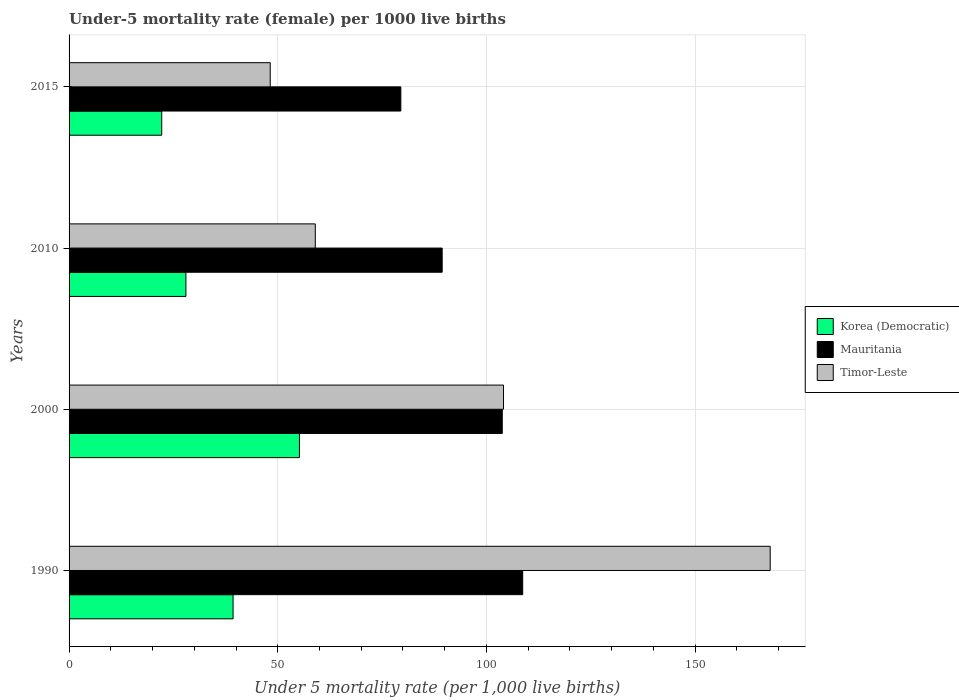How many groups of bars are there?
Provide a succinct answer. 4. Are the number of bars per tick equal to the number of legend labels?
Your answer should be very brief. Yes. How many bars are there on the 2nd tick from the top?
Your answer should be compact. 3. How many bars are there on the 1st tick from the bottom?
Your answer should be very brief. 3. What is the label of the 1st group of bars from the top?
Ensure brevity in your answer.  2015. In how many cases, is the number of bars for a given year not equal to the number of legend labels?
Provide a succinct answer. 0. What is the under-five mortality rate in Korea (Democratic) in 1990?
Offer a terse response. 39.3. Across all years, what is the maximum under-five mortality rate in Korea (Democratic)?
Your answer should be compact. 55.2. Across all years, what is the minimum under-five mortality rate in Mauritania?
Provide a short and direct response. 79.5. In which year was the under-five mortality rate in Timor-Leste minimum?
Make the answer very short. 2015. What is the total under-five mortality rate in Mauritania in the graph?
Provide a short and direct response. 381.4. What is the difference between the under-five mortality rate in Mauritania in 2000 and that in 2010?
Give a very brief answer. 14.4. What is the difference between the under-five mortality rate in Korea (Democratic) in 1990 and the under-five mortality rate in Timor-Leste in 2015?
Provide a short and direct response. -8.9. What is the average under-five mortality rate in Korea (Democratic) per year?
Ensure brevity in your answer.  36.17. In the year 1990, what is the difference between the under-five mortality rate in Mauritania and under-five mortality rate in Korea (Democratic)?
Offer a very short reply. 69.4. In how many years, is the under-five mortality rate in Timor-Leste greater than 30 ?
Keep it short and to the point. 4. What is the ratio of the under-five mortality rate in Timor-Leste in 1990 to that in 2015?
Provide a short and direct response. 3.49. Is the under-five mortality rate in Timor-Leste in 1990 less than that in 2000?
Keep it short and to the point. No. What is the difference between the highest and the second highest under-five mortality rate in Mauritania?
Your response must be concise. 4.9. What is the difference between the highest and the lowest under-five mortality rate in Timor-Leste?
Make the answer very short. 119.8. In how many years, is the under-five mortality rate in Timor-Leste greater than the average under-five mortality rate in Timor-Leste taken over all years?
Your response must be concise. 2. What does the 3rd bar from the top in 2015 represents?
Offer a very short reply. Korea (Democratic). What does the 3rd bar from the bottom in 2000 represents?
Make the answer very short. Timor-Leste. Is it the case that in every year, the sum of the under-five mortality rate in Timor-Leste and under-five mortality rate in Korea (Democratic) is greater than the under-five mortality rate in Mauritania?
Your answer should be very brief. No. How many years are there in the graph?
Your answer should be very brief. 4. Does the graph contain grids?
Offer a terse response. Yes. Where does the legend appear in the graph?
Your response must be concise. Center right. How many legend labels are there?
Ensure brevity in your answer.  3. What is the title of the graph?
Ensure brevity in your answer.  Under-5 mortality rate (female) per 1000 live births. Does "Luxembourg" appear as one of the legend labels in the graph?
Keep it short and to the point. No. What is the label or title of the X-axis?
Your answer should be compact. Under 5 mortality rate (per 1,0 live births). What is the label or title of the Y-axis?
Your response must be concise. Years. What is the Under 5 mortality rate (per 1,000 live births) in Korea (Democratic) in 1990?
Your answer should be very brief. 39.3. What is the Under 5 mortality rate (per 1,000 live births) in Mauritania in 1990?
Keep it short and to the point. 108.7. What is the Under 5 mortality rate (per 1,000 live births) in Timor-Leste in 1990?
Ensure brevity in your answer.  168. What is the Under 5 mortality rate (per 1,000 live births) in Korea (Democratic) in 2000?
Provide a short and direct response. 55.2. What is the Under 5 mortality rate (per 1,000 live births) in Mauritania in 2000?
Your answer should be compact. 103.8. What is the Under 5 mortality rate (per 1,000 live births) in Timor-Leste in 2000?
Offer a very short reply. 104.1. What is the Under 5 mortality rate (per 1,000 live births) in Korea (Democratic) in 2010?
Provide a succinct answer. 28. What is the Under 5 mortality rate (per 1,000 live births) of Mauritania in 2010?
Provide a short and direct response. 89.4. What is the Under 5 mortality rate (per 1,000 live births) of Timor-Leste in 2010?
Provide a succinct answer. 59. What is the Under 5 mortality rate (per 1,000 live births) in Mauritania in 2015?
Offer a very short reply. 79.5. What is the Under 5 mortality rate (per 1,000 live births) of Timor-Leste in 2015?
Ensure brevity in your answer.  48.2. Across all years, what is the maximum Under 5 mortality rate (per 1,000 live births) in Korea (Democratic)?
Make the answer very short. 55.2. Across all years, what is the maximum Under 5 mortality rate (per 1,000 live births) in Mauritania?
Offer a very short reply. 108.7. Across all years, what is the maximum Under 5 mortality rate (per 1,000 live births) of Timor-Leste?
Your answer should be very brief. 168. Across all years, what is the minimum Under 5 mortality rate (per 1,000 live births) in Mauritania?
Offer a terse response. 79.5. Across all years, what is the minimum Under 5 mortality rate (per 1,000 live births) of Timor-Leste?
Make the answer very short. 48.2. What is the total Under 5 mortality rate (per 1,000 live births) in Korea (Democratic) in the graph?
Your answer should be very brief. 144.7. What is the total Under 5 mortality rate (per 1,000 live births) of Mauritania in the graph?
Keep it short and to the point. 381.4. What is the total Under 5 mortality rate (per 1,000 live births) in Timor-Leste in the graph?
Offer a terse response. 379.3. What is the difference between the Under 5 mortality rate (per 1,000 live births) of Korea (Democratic) in 1990 and that in 2000?
Make the answer very short. -15.9. What is the difference between the Under 5 mortality rate (per 1,000 live births) in Timor-Leste in 1990 and that in 2000?
Offer a very short reply. 63.9. What is the difference between the Under 5 mortality rate (per 1,000 live births) in Korea (Democratic) in 1990 and that in 2010?
Provide a succinct answer. 11.3. What is the difference between the Under 5 mortality rate (per 1,000 live births) of Mauritania in 1990 and that in 2010?
Your answer should be very brief. 19.3. What is the difference between the Under 5 mortality rate (per 1,000 live births) of Timor-Leste in 1990 and that in 2010?
Offer a terse response. 109. What is the difference between the Under 5 mortality rate (per 1,000 live births) in Korea (Democratic) in 1990 and that in 2015?
Your response must be concise. 17.1. What is the difference between the Under 5 mortality rate (per 1,000 live births) in Mauritania in 1990 and that in 2015?
Provide a short and direct response. 29.2. What is the difference between the Under 5 mortality rate (per 1,000 live births) in Timor-Leste in 1990 and that in 2015?
Ensure brevity in your answer.  119.8. What is the difference between the Under 5 mortality rate (per 1,000 live births) in Korea (Democratic) in 2000 and that in 2010?
Your answer should be very brief. 27.2. What is the difference between the Under 5 mortality rate (per 1,000 live births) of Timor-Leste in 2000 and that in 2010?
Your answer should be very brief. 45.1. What is the difference between the Under 5 mortality rate (per 1,000 live births) in Mauritania in 2000 and that in 2015?
Offer a very short reply. 24.3. What is the difference between the Under 5 mortality rate (per 1,000 live births) of Timor-Leste in 2000 and that in 2015?
Your response must be concise. 55.9. What is the difference between the Under 5 mortality rate (per 1,000 live births) in Korea (Democratic) in 1990 and the Under 5 mortality rate (per 1,000 live births) in Mauritania in 2000?
Offer a terse response. -64.5. What is the difference between the Under 5 mortality rate (per 1,000 live births) of Korea (Democratic) in 1990 and the Under 5 mortality rate (per 1,000 live births) of Timor-Leste in 2000?
Your answer should be compact. -64.8. What is the difference between the Under 5 mortality rate (per 1,000 live births) in Mauritania in 1990 and the Under 5 mortality rate (per 1,000 live births) in Timor-Leste in 2000?
Make the answer very short. 4.6. What is the difference between the Under 5 mortality rate (per 1,000 live births) of Korea (Democratic) in 1990 and the Under 5 mortality rate (per 1,000 live births) of Mauritania in 2010?
Your response must be concise. -50.1. What is the difference between the Under 5 mortality rate (per 1,000 live births) in Korea (Democratic) in 1990 and the Under 5 mortality rate (per 1,000 live births) in Timor-Leste in 2010?
Make the answer very short. -19.7. What is the difference between the Under 5 mortality rate (per 1,000 live births) of Mauritania in 1990 and the Under 5 mortality rate (per 1,000 live births) of Timor-Leste in 2010?
Offer a terse response. 49.7. What is the difference between the Under 5 mortality rate (per 1,000 live births) of Korea (Democratic) in 1990 and the Under 5 mortality rate (per 1,000 live births) of Mauritania in 2015?
Offer a very short reply. -40.2. What is the difference between the Under 5 mortality rate (per 1,000 live births) in Mauritania in 1990 and the Under 5 mortality rate (per 1,000 live births) in Timor-Leste in 2015?
Keep it short and to the point. 60.5. What is the difference between the Under 5 mortality rate (per 1,000 live births) of Korea (Democratic) in 2000 and the Under 5 mortality rate (per 1,000 live births) of Mauritania in 2010?
Your response must be concise. -34.2. What is the difference between the Under 5 mortality rate (per 1,000 live births) of Korea (Democratic) in 2000 and the Under 5 mortality rate (per 1,000 live births) of Timor-Leste in 2010?
Give a very brief answer. -3.8. What is the difference between the Under 5 mortality rate (per 1,000 live births) in Mauritania in 2000 and the Under 5 mortality rate (per 1,000 live births) in Timor-Leste in 2010?
Your response must be concise. 44.8. What is the difference between the Under 5 mortality rate (per 1,000 live births) in Korea (Democratic) in 2000 and the Under 5 mortality rate (per 1,000 live births) in Mauritania in 2015?
Provide a succinct answer. -24.3. What is the difference between the Under 5 mortality rate (per 1,000 live births) in Mauritania in 2000 and the Under 5 mortality rate (per 1,000 live births) in Timor-Leste in 2015?
Provide a succinct answer. 55.6. What is the difference between the Under 5 mortality rate (per 1,000 live births) in Korea (Democratic) in 2010 and the Under 5 mortality rate (per 1,000 live births) in Mauritania in 2015?
Your answer should be compact. -51.5. What is the difference between the Under 5 mortality rate (per 1,000 live births) in Korea (Democratic) in 2010 and the Under 5 mortality rate (per 1,000 live births) in Timor-Leste in 2015?
Provide a succinct answer. -20.2. What is the difference between the Under 5 mortality rate (per 1,000 live births) in Mauritania in 2010 and the Under 5 mortality rate (per 1,000 live births) in Timor-Leste in 2015?
Give a very brief answer. 41.2. What is the average Under 5 mortality rate (per 1,000 live births) in Korea (Democratic) per year?
Your answer should be very brief. 36.17. What is the average Under 5 mortality rate (per 1,000 live births) of Mauritania per year?
Your answer should be compact. 95.35. What is the average Under 5 mortality rate (per 1,000 live births) of Timor-Leste per year?
Make the answer very short. 94.83. In the year 1990, what is the difference between the Under 5 mortality rate (per 1,000 live births) in Korea (Democratic) and Under 5 mortality rate (per 1,000 live births) in Mauritania?
Provide a succinct answer. -69.4. In the year 1990, what is the difference between the Under 5 mortality rate (per 1,000 live births) of Korea (Democratic) and Under 5 mortality rate (per 1,000 live births) of Timor-Leste?
Ensure brevity in your answer.  -128.7. In the year 1990, what is the difference between the Under 5 mortality rate (per 1,000 live births) in Mauritania and Under 5 mortality rate (per 1,000 live births) in Timor-Leste?
Give a very brief answer. -59.3. In the year 2000, what is the difference between the Under 5 mortality rate (per 1,000 live births) in Korea (Democratic) and Under 5 mortality rate (per 1,000 live births) in Mauritania?
Keep it short and to the point. -48.6. In the year 2000, what is the difference between the Under 5 mortality rate (per 1,000 live births) of Korea (Democratic) and Under 5 mortality rate (per 1,000 live births) of Timor-Leste?
Your response must be concise. -48.9. In the year 2010, what is the difference between the Under 5 mortality rate (per 1,000 live births) of Korea (Democratic) and Under 5 mortality rate (per 1,000 live births) of Mauritania?
Offer a very short reply. -61.4. In the year 2010, what is the difference between the Under 5 mortality rate (per 1,000 live births) in Korea (Democratic) and Under 5 mortality rate (per 1,000 live births) in Timor-Leste?
Ensure brevity in your answer.  -31. In the year 2010, what is the difference between the Under 5 mortality rate (per 1,000 live births) of Mauritania and Under 5 mortality rate (per 1,000 live births) of Timor-Leste?
Make the answer very short. 30.4. In the year 2015, what is the difference between the Under 5 mortality rate (per 1,000 live births) of Korea (Democratic) and Under 5 mortality rate (per 1,000 live births) of Mauritania?
Your answer should be very brief. -57.3. In the year 2015, what is the difference between the Under 5 mortality rate (per 1,000 live births) of Korea (Democratic) and Under 5 mortality rate (per 1,000 live births) of Timor-Leste?
Offer a terse response. -26. In the year 2015, what is the difference between the Under 5 mortality rate (per 1,000 live births) in Mauritania and Under 5 mortality rate (per 1,000 live births) in Timor-Leste?
Give a very brief answer. 31.3. What is the ratio of the Under 5 mortality rate (per 1,000 live births) in Korea (Democratic) in 1990 to that in 2000?
Give a very brief answer. 0.71. What is the ratio of the Under 5 mortality rate (per 1,000 live births) of Mauritania in 1990 to that in 2000?
Your answer should be compact. 1.05. What is the ratio of the Under 5 mortality rate (per 1,000 live births) of Timor-Leste in 1990 to that in 2000?
Offer a very short reply. 1.61. What is the ratio of the Under 5 mortality rate (per 1,000 live births) in Korea (Democratic) in 1990 to that in 2010?
Provide a short and direct response. 1.4. What is the ratio of the Under 5 mortality rate (per 1,000 live births) in Mauritania in 1990 to that in 2010?
Provide a succinct answer. 1.22. What is the ratio of the Under 5 mortality rate (per 1,000 live births) of Timor-Leste in 1990 to that in 2010?
Offer a very short reply. 2.85. What is the ratio of the Under 5 mortality rate (per 1,000 live births) in Korea (Democratic) in 1990 to that in 2015?
Offer a very short reply. 1.77. What is the ratio of the Under 5 mortality rate (per 1,000 live births) in Mauritania in 1990 to that in 2015?
Offer a very short reply. 1.37. What is the ratio of the Under 5 mortality rate (per 1,000 live births) in Timor-Leste in 1990 to that in 2015?
Ensure brevity in your answer.  3.49. What is the ratio of the Under 5 mortality rate (per 1,000 live births) of Korea (Democratic) in 2000 to that in 2010?
Your answer should be very brief. 1.97. What is the ratio of the Under 5 mortality rate (per 1,000 live births) in Mauritania in 2000 to that in 2010?
Ensure brevity in your answer.  1.16. What is the ratio of the Under 5 mortality rate (per 1,000 live births) of Timor-Leste in 2000 to that in 2010?
Keep it short and to the point. 1.76. What is the ratio of the Under 5 mortality rate (per 1,000 live births) of Korea (Democratic) in 2000 to that in 2015?
Your answer should be compact. 2.49. What is the ratio of the Under 5 mortality rate (per 1,000 live births) in Mauritania in 2000 to that in 2015?
Your response must be concise. 1.31. What is the ratio of the Under 5 mortality rate (per 1,000 live births) in Timor-Leste in 2000 to that in 2015?
Keep it short and to the point. 2.16. What is the ratio of the Under 5 mortality rate (per 1,000 live births) in Korea (Democratic) in 2010 to that in 2015?
Offer a very short reply. 1.26. What is the ratio of the Under 5 mortality rate (per 1,000 live births) of Mauritania in 2010 to that in 2015?
Offer a terse response. 1.12. What is the ratio of the Under 5 mortality rate (per 1,000 live births) of Timor-Leste in 2010 to that in 2015?
Ensure brevity in your answer.  1.22. What is the difference between the highest and the second highest Under 5 mortality rate (per 1,000 live births) in Mauritania?
Make the answer very short. 4.9. What is the difference between the highest and the second highest Under 5 mortality rate (per 1,000 live births) in Timor-Leste?
Provide a short and direct response. 63.9. What is the difference between the highest and the lowest Under 5 mortality rate (per 1,000 live births) of Mauritania?
Ensure brevity in your answer.  29.2. What is the difference between the highest and the lowest Under 5 mortality rate (per 1,000 live births) of Timor-Leste?
Keep it short and to the point. 119.8. 